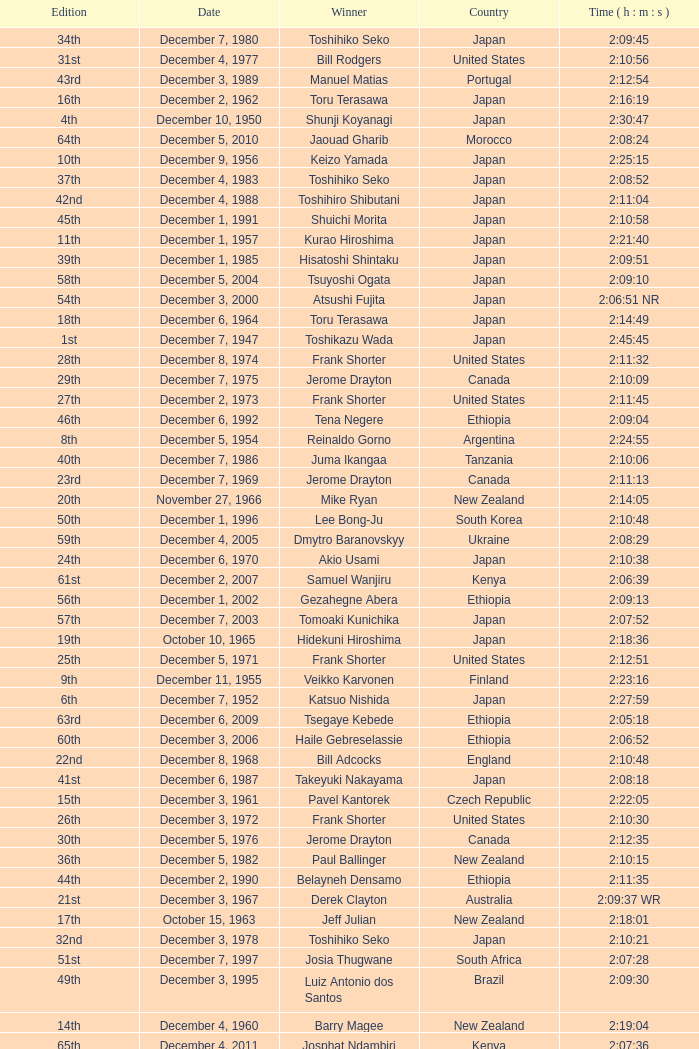What was the nationality of the winner on December 8, 1968? England. 